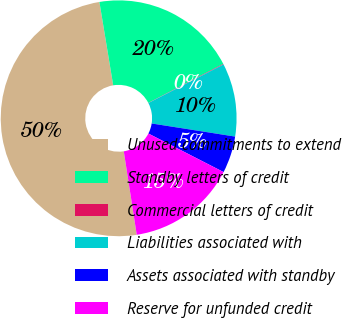Convert chart. <chart><loc_0><loc_0><loc_500><loc_500><pie_chart><fcel>Unused commitments to extend<fcel>Standby letters of credit<fcel>Commercial letters of credit<fcel>Liabilities associated with<fcel>Assets associated with standby<fcel>Reserve for unfunded credit<nl><fcel>49.84%<fcel>19.98%<fcel>0.08%<fcel>10.03%<fcel>5.06%<fcel>15.01%<nl></chart> 